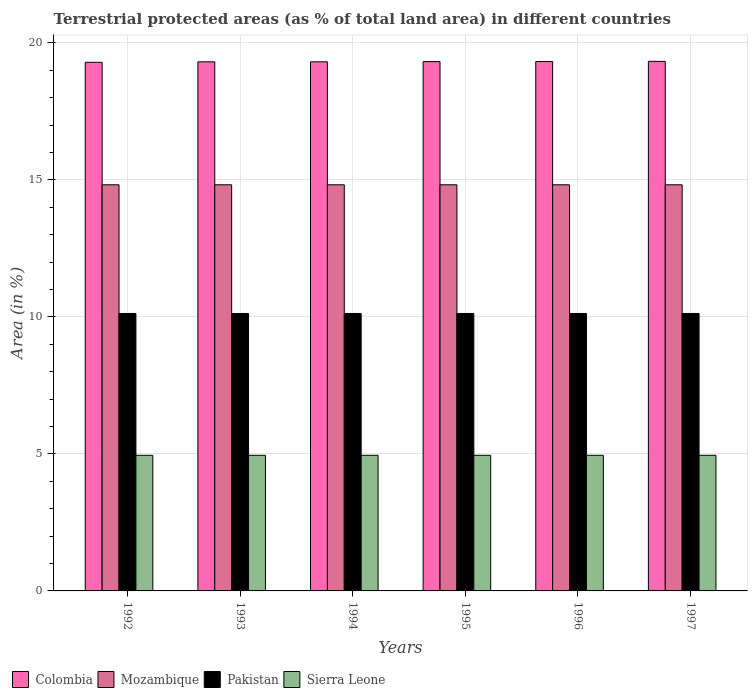How many bars are there on the 3rd tick from the left?
Offer a very short reply. 4. How many bars are there on the 2nd tick from the right?
Your answer should be compact. 4. What is the label of the 4th group of bars from the left?
Give a very brief answer. 1995. In how many cases, is the number of bars for a given year not equal to the number of legend labels?
Your answer should be very brief. 0. What is the percentage of terrestrial protected land in Mozambique in 1992?
Provide a short and direct response. 14.82. Across all years, what is the maximum percentage of terrestrial protected land in Colombia?
Offer a terse response. 19.33. Across all years, what is the minimum percentage of terrestrial protected land in Sierra Leone?
Make the answer very short. 4.95. What is the total percentage of terrestrial protected land in Pakistan in the graph?
Your answer should be very brief. 60.75. What is the difference between the percentage of terrestrial protected land in Sierra Leone in 1993 and the percentage of terrestrial protected land in Mozambique in 1994?
Your answer should be compact. -9.87. What is the average percentage of terrestrial protected land in Colombia per year?
Give a very brief answer. 19.31. In the year 1995, what is the difference between the percentage of terrestrial protected land in Mozambique and percentage of terrestrial protected land in Colombia?
Your answer should be very brief. -4.5. What is the ratio of the percentage of terrestrial protected land in Pakistan in 1993 to that in 1995?
Your response must be concise. 1. Is the percentage of terrestrial protected land in Pakistan in 1993 less than that in 1997?
Your answer should be very brief. No. What is the difference between the highest and the second highest percentage of terrestrial protected land in Sierra Leone?
Offer a terse response. 0. What is the difference between the highest and the lowest percentage of terrestrial protected land in Colombia?
Offer a very short reply. 0.03. Is it the case that in every year, the sum of the percentage of terrestrial protected land in Pakistan and percentage of terrestrial protected land in Colombia is greater than the sum of percentage of terrestrial protected land in Sierra Leone and percentage of terrestrial protected land in Mozambique?
Keep it short and to the point. No. How many bars are there?
Offer a terse response. 24. Are all the bars in the graph horizontal?
Provide a short and direct response. No. How many years are there in the graph?
Ensure brevity in your answer.  6. Where does the legend appear in the graph?
Provide a succinct answer. Bottom left. How many legend labels are there?
Keep it short and to the point. 4. What is the title of the graph?
Offer a terse response. Terrestrial protected areas (as % of total land area) in different countries. What is the label or title of the Y-axis?
Offer a very short reply. Area (in %). What is the Area (in %) of Colombia in 1992?
Your answer should be compact. 19.29. What is the Area (in %) in Mozambique in 1992?
Provide a short and direct response. 14.82. What is the Area (in %) of Pakistan in 1992?
Offer a very short reply. 10.13. What is the Area (in %) of Sierra Leone in 1992?
Provide a short and direct response. 4.95. What is the Area (in %) of Colombia in 1993?
Keep it short and to the point. 19.31. What is the Area (in %) in Mozambique in 1993?
Provide a short and direct response. 14.82. What is the Area (in %) of Pakistan in 1993?
Keep it short and to the point. 10.13. What is the Area (in %) of Sierra Leone in 1993?
Your answer should be compact. 4.95. What is the Area (in %) in Colombia in 1994?
Provide a short and direct response. 19.31. What is the Area (in %) in Mozambique in 1994?
Ensure brevity in your answer.  14.82. What is the Area (in %) of Pakistan in 1994?
Your answer should be very brief. 10.13. What is the Area (in %) of Sierra Leone in 1994?
Your answer should be very brief. 4.95. What is the Area (in %) in Colombia in 1995?
Your answer should be very brief. 19.32. What is the Area (in %) in Mozambique in 1995?
Provide a succinct answer. 14.82. What is the Area (in %) in Pakistan in 1995?
Offer a terse response. 10.13. What is the Area (in %) of Sierra Leone in 1995?
Keep it short and to the point. 4.95. What is the Area (in %) in Colombia in 1996?
Ensure brevity in your answer.  19.32. What is the Area (in %) of Mozambique in 1996?
Offer a terse response. 14.82. What is the Area (in %) in Pakistan in 1996?
Ensure brevity in your answer.  10.13. What is the Area (in %) in Sierra Leone in 1996?
Offer a very short reply. 4.95. What is the Area (in %) in Colombia in 1997?
Ensure brevity in your answer.  19.33. What is the Area (in %) of Mozambique in 1997?
Keep it short and to the point. 14.82. What is the Area (in %) in Pakistan in 1997?
Keep it short and to the point. 10.13. What is the Area (in %) of Sierra Leone in 1997?
Provide a succinct answer. 4.95. Across all years, what is the maximum Area (in %) in Colombia?
Offer a very short reply. 19.33. Across all years, what is the maximum Area (in %) of Mozambique?
Provide a short and direct response. 14.82. Across all years, what is the maximum Area (in %) in Pakistan?
Provide a short and direct response. 10.13. Across all years, what is the maximum Area (in %) of Sierra Leone?
Give a very brief answer. 4.95. Across all years, what is the minimum Area (in %) in Colombia?
Provide a short and direct response. 19.29. Across all years, what is the minimum Area (in %) of Mozambique?
Keep it short and to the point. 14.82. Across all years, what is the minimum Area (in %) of Pakistan?
Your answer should be compact. 10.13. Across all years, what is the minimum Area (in %) in Sierra Leone?
Your answer should be very brief. 4.95. What is the total Area (in %) in Colombia in the graph?
Make the answer very short. 115.87. What is the total Area (in %) in Mozambique in the graph?
Your answer should be compact. 88.93. What is the total Area (in %) of Pakistan in the graph?
Ensure brevity in your answer.  60.75. What is the total Area (in %) of Sierra Leone in the graph?
Offer a very short reply. 29.7. What is the difference between the Area (in %) of Colombia in 1992 and that in 1993?
Keep it short and to the point. -0.02. What is the difference between the Area (in %) in Pakistan in 1992 and that in 1993?
Ensure brevity in your answer.  0. What is the difference between the Area (in %) of Colombia in 1992 and that in 1994?
Ensure brevity in your answer.  -0.02. What is the difference between the Area (in %) in Mozambique in 1992 and that in 1994?
Provide a short and direct response. 0. What is the difference between the Area (in %) of Pakistan in 1992 and that in 1994?
Give a very brief answer. 0. What is the difference between the Area (in %) of Sierra Leone in 1992 and that in 1994?
Your response must be concise. 0. What is the difference between the Area (in %) in Colombia in 1992 and that in 1995?
Provide a succinct answer. -0.03. What is the difference between the Area (in %) in Colombia in 1992 and that in 1996?
Provide a short and direct response. -0.03. What is the difference between the Area (in %) in Mozambique in 1992 and that in 1996?
Give a very brief answer. 0. What is the difference between the Area (in %) in Colombia in 1992 and that in 1997?
Your response must be concise. -0.03. What is the difference between the Area (in %) in Sierra Leone in 1992 and that in 1997?
Your answer should be very brief. 0. What is the difference between the Area (in %) in Colombia in 1993 and that in 1994?
Make the answer very short. 0. What is the difference between the Area (in %) in Mozambique in 1993 and that in 1994?
Make the answer very short. 0. What is the difference between the Area (in %) in Pakistan in 1993 and that in 1994?
Make the answer very short. 0. What is the difference between the Area (in %) of Sierra Leone in 1993 and that in 1994?
Offer a terse response. 0. What is the difference between the Area (in %) in Colombia in 1993 and that in 1995?
Keep it short and to the point. -0.01. What is the difference between the Area (in %) in Mozambique in 1993 and that in 1995?
Provide a short and direct response. 0. What is the difference between the Area (in %) in Pakistan in 1993 and that in 1995?
Your answer should be compact. 0. What is the difference between the Area (in %) in Colombia in 1993 and that in 1996?
Your response must be concise. -0.01. What is the difference between the Area (in %) in Mozambique in 1993 and that in 1996?
Ensure brevity in your answer.  0. What is the difference between the Area (in %) of Colombia in 1993 and that in 1997?
Give a very brief answer. -0.02. What is the difference between the Area (in %) in Mozambique in 1993 and that in 1997?
Offer a very short reply. 0. What is the difference between the Area (in %) in Pakistan in 1993 and that in 1997?
Offer a terse response. 0. What is the difference between the Area (in %) of Sierra Leone in 1993 and that in 1997?
Keep it short and to the point. 0. What is the difference between the Area (in %) in Colombia in 1994 and that in 1995?
Make the answer very short. -0.01. What is the difference between the Area (in %) in Mozambique in 1994 and that in 1995?
Your response must be concise. 0. What is the difference between the Area (in %) in Pakistan in 1994 and that in 1995?
Make the answer very short. 0. What is the difference between the Area (in %) in Sierra Leone in 1994 and that in 1995?
Provide a succinct answer. 0. What is the difference between the Area (in %) of Colombia in 1994 and that in 1996?
Give a very brief answer. -0.01. What is the difference between the Area (in %) in Mozambique in 1994 and that in 1996?
Give a very brief answer. 0. What is the difference between the Area (in %) in Colombia in 1994 and that in 1997?
Your answer should be compact. -0.02. What is the difference between the Area (in %) of Pakistan in 1994 and that in 1997?
Keep it short and to the point. 0. What is the difference between the Area (in %) in Colombia in 1995 and that in 1996?
Offer a very short reply. -0. What is the difference between the Area (in %) in Mozambique in 1995 and that in 1996?
Offer a very short reply. 0. What is the difference between the Area (in %) in Sierra Leone in 1995 and that in 1996?
Ensure brevity in your answer.  0. What is the difference between the Area (in %) in Colombia in 1995 and that in 1997?
Offer a terse response. -0.01. What is the difference between the Area (in %) in Pakistan in 1995 and that in 1997?
Give a very brief answer. 0. What is the difference between the Area (in %) in Sierra Leone in 1995 and that in 1997?
Make the answer very short. 0. What is the difference between the Area (in %) of Colombia in 1996 and that in 1997?
Provide a short and direct response. -0.01. What is the difference between the Area (in %) in Sierra Leone in 1996 and that in 1997?
Your answer should be very brief. 0. What is the difference between the Area (in %) of Colombia in 1992 and the Area (in %) of Mozambique in 1993?
Provide a short and direct response. 4.47. What is the difference between the Area (in %) of Colombia in 1992 and the Area (in %) of Pakistan in 1993?
Offer a terse response. 9.17. What is the difference between the Area (in %) of Colombia in 1992 and the Area (in %) of Sierra Leone in 1993?
Provide a short and direct response. 14.34. What is the difference between the Area (in %) of Mozambique in 1992 and the Area (in %) of Pakistan in 1993?
Provide a succinct answer. 4.7. What is the difference between the Area (in %) of Mozambique in 1992 and the Area (in %) of Sierra Leone in 1993?
Keep it short and to the point. 9.87. What is the difference between the Area (in %) of Pakistan in 1992 and the Area (in %) of Sierra Leone in 1993?
Your response must be concise. 5.18. What is the difference between the Area (in %) of Colombia in 1992 and the Area (in %) of Mozambique in 1994?
Make the answer very short. 4.47. What is the difference between the Area (in %) in Colombia in 1992 and the Area (in %) in Pakistan in 1994?
Provide a succinct answer. 9.17. What is the difference between the Area (in %) in Colombia in 1992 and the Area (in %) in Sierra Leone in 1994?
Your answer should be compact. 14.34. What is the difference between the Area (in %) of Mozambique in 1992 and the Area (in %) of Pakistan in 1994?
Provide a succinct answer. 4.7. What is the difference between the Area (in %) of Mozambique in 1992 and the Area (in %) of Sierra Leone in 1994?
Ensure brevity in your answer.  9.87. What is the difference between the Area (in %) of Pakistan in 1992 and the Area (in %) of Sierra Leone in 1994?
Offer a terse response. 5.18. What is the difference between the Area (in %) of Colombia in 1992 and the Area (in %) of Mozambique in 1995?
Provide a succinct answer. 4.47. What is the difference between the Area (in %) of Colombia in 1992 and the Area (in %) of Pakistan in 1995?
Your answer should be compact. 9.17. What is the difference between the Area (in %) of Colombia in 1992 and the Area (in %) of Sierra Leone in 1995?
Make the answer very short. 14.34. What is the difference between the Area (in %) in Mozambique in 1992 and the Area (in %) in Pakistan in 1995?
Your response must be concise. 4.7. What is the difference between the Area (in %) of Mozambique in 1992 and the Area (in %) of Sierra Leone in 1995?
Keep it short and to the point. 9.87. What is the difference between the Area (in %) of Pakistan in 1992 and the Area (in %) of Sierra Leone in 1995?
Your response must be concise. 5.18. What is the difference between the Area (in %) of Colombia in 1992 and the Area (in %) of Mozambique in 1996?
Provide a succinct answer. 4.47. What is the difference between the Area (in %) of Colombia in 1992 and the Area (in %) of Pakistan in 1996?
Provide a succinct answer. 9.17. What is the difference between the Area (in %) of Colombia in 1992 and the Area (in %) of Sierra Leone in 1996?
Ensure brevity in your answer.  14.34. What is the difference between the Area (in %) in Mozambique in 1992 and the Area (in %) in Pakistan in 1996?
Offer a very short reply. 4.7. What is the difference between the Area (in %) in Mozambique in 1992 and the Area (in %) in Sierra Leone in 1996?
Offer a very short reply. 9.87. What is the difference between the Area (in %) of Pakistan in 1992 and the Area (in %) of Sierra Leone in 1996?
Your response must be concise. 5.18. What is the difference between the Area (in %) of Colombia in 1992 and the Area (in %) of Mozambique in 1997?
Your response must be concise. 4.47. What is the difference between the Area (in %) of Colombia in 1992 and the Area (in %) of Pakistan in 1997?
Ensure brevity in your answer.  9.17. What is the difference between the Area (in %) in Colombia in 1992 and the Area (in %) in Sierra Leone in 1997?
Your response must be concise. 14.34. What is the difference between the Area (in %) in Mozambique in 1992 and the Area (in %) in Pakistan in 1997?
Provide a short and direct response. 4.7. What is the difference between the Area (in %) in Mozambique in 1992 and the Area (in %) in Sierra Leone in 1997?
Your response must be concise. 9.87. What is the difference between the Area (in %) of Pakistan in 1992 and the Area (in %) of Sierra Leone in 1997?
Provide a short and direct response. 5.18. What is the difference between the Area (in %) of Colombia in 1993 and the Area (in %) of Mozambique in 1994?
Keep it short and to the point. 4.49. What is the difference between the Area (in %) in Colombia in 1993 and the Area (in %) in Pakistan in 1994?
Keep it short and to the point. 9.18. What is the difference between the Area (in %) in Colombia in 1993 and the Area (in %) in Sierra Leone in 1994?
Your response must be concise. 14.36. What is the difference between the Area (in %) in Mozambique in 1993 and the Area (in %) in Pakistan in 1994?
Give a very brief answer. 4.7. What is the difference between the Area (in %) of Mozambique in 1993 and the Area (in %) of Sierra Leone in 1994?
Make the answer very short. 9.87. What is the difference between the Area (in %) of Pakistan in 1993 and the Area (in %) of Sierra Leone in 1994?
Keep it short and to the point. 5.18. What is the difference between the Area (in %) of Colombia in 1993 and the Area (in %) of Mozambique in 1995?
Ensure brevity in your answer.  4.49. What is the difference between the Area (in %) of Colombia in 1993 and the Area (in %) of Pakistan in 1995?
Offer a very short reply. 9.18. What is the difference between the Area (in %) in Colombia in 1993 and the Area (in %) in Sierra Leone in 1995?
Give a very brief answer. 14.36. What is the difference between the Area (in %) in Mozambique in 1993 and the Area (in %) in Pakistan in 1995?
Provide a succinct answer. 4.7. What is the difference between the Area (in %) of Mozambique in 1993 and the Area (in %) of Sierra Leone in 1995?
Offer a terse response. 9.87. What is the difference between the Area (in %) of Pakistan in 1993 and the Area (in %) of Sierra Leone in 1995?
Offer a very short reply. 5.18. What is the difference between the Area (in %) in Colombia in 1993 and the Area (in %) in Mozambique in 1996?
Provide a succinct answer. 4.49. What is the difference between the Area (in %) of Colombia in 1993 and the Area (in %) of Pakistan in 1996?
Your answer should be very brief. 9.18. What is the difference between the Area (in %) in Colombia in 1993 and the Area (in %) in Sierra Leone in 1996?
Ensure brevity in your answer.  14.36. What is the difference between the Area (in %) of Mozambique in 1993 and the Area (in %) of Pakistan in 1996?
Give a very brief answer. 4.7. What is the difference between the Area (in %) in Mozambique in 1993 and the Area (in %) in Sierra Leone in 1996?
Offer a terse response. 9.87. What is the difference between the Area (in %) in Pakistan in 1993 and the Area (in %) in Sierra Leone in 1996?
Make the answer very short. 5.18. What is the difference between the Area (in %) in Colombia in 1993 and the Area (in %) in Mozambique in 1997?
Your response must be concise. 4.49. What is the difference between the Area (in %) in Colombia in 1993 and the Area (in %) in Pakistan in 1997?
Give a very brief answer. 9.18. What is the difference between the Area (in %) in Colombia in 1993 and the Area (in %) in Sierra Leone in 1997?
Your answer should be compact. 14.36. What is the difference between the Area (in %) in Mozambique in 1993 and the Area (in %) in Pakistan in 1997?
Ensure brevity in your answer.  4.7. What is the difference between the Area (in %) of Mozambique in 1993 and the Area (in %) of Sierra Leone in 1997?
Offer a very short reply. 9.87. What is the difference between the Area (in %) of Pakistan in 1993 and the Area (in %) of Sierra Leone in 1997?
Offer a very short reply. 5.18. What is the difference between the Area (in %) of Colombia in 1994 and the Area (in %) of Mozambique in 1995?
Your answer should be very brief. 4.49. What is the difference between the Area (in %) of Colombia in 1994 and the Area (in %) of Pakistan in 1995?
Your answer should be compact. 9.18. What is the difference between the Area (in %) in Colombia in 1994 and the Area (in %) in Sierra Leone in 1995?
Make the answer very short. 14.36. What is the difference between the Area (in %) of Mozambique in 1994 and the Area (in %) of Pakistan in 1995?
Make the answer very short. 4.7. What is the difference between the Area (in %) in Mozambique in 1994 and the Area (in %) in Sierra Leone in 1995?
Ensure brevity in your answer.  9.87. What is the difference between the Area (in %) in Pakistan in 1994 and the Area (in %) in Sierra Leone in 1995?
Your answer should be compact. 5.18. What is the difference between the Area (in %) of Colombia in 1994 and the Area (in %) of Mozambique in 1996?
Ensure brevity in your answer.  4.49. What is the difference between the Area (in %) in Colombia in 1994 and the Area (in %) in Pakistan in 1996?
Give a very brief answer. 9.18. What is the difference between the Area (in %) in Colombia in 1994 and the Area (in %) in Sierra Leone in 1996?
Keep it short and to the point. 14.36. What is the difference between the Area (in %) in Mozambique in 1994 and the Area (in %) in Pakistan in 1996?
Your answer should be compact. 4.7. What is the difference between the Area (in %) of Mozambique in 1994 and the Area (in %) of Sierra Leone in 1996?
Make the answer very short. 9.87. What is the difference between the Area (in %) of Pakistan in 1994 and the Area (in %) of Sierra Leone in 1996?
Offer a very short reply. 5.18. What is the difference between the Area (in %) in Colombia in 1994 and the Area (in %) in Mozambique in 1997?
Keep it short and to the point. 4.49. What is the difference between the Area (in %) of Colombia in 1994 and the Area (in %) of Pakistan in 1997?
Offer a very short reply. 9.18. What is the difference between the Area (in %) in Colombia in 1994 and the Area (in %) in Sierra Leone in 1997?
Keep it short and to the point. 14.36. What is the difference between the Area (in %) of Mozambique in 1994 and the Area (in %) of Pakistan in 1997?
Keep it short and to the point. 4.7. What is the difference between the Area (in %) in Mozambique in 1994 and the Area (in %) in Sierra Leone in 1997?
Keep it short and to the point. 9.87. What is the difference between the Area (in %) in Pakistan in 1994 and the Area (in %) in Sierra Leone in 1997?
Offer a very short reply. 5.18. What is the difference between the Area (in %) in Colombia in 1995 and the Area (in %) in Mozambique in 1996?
Provide a succinct answer. 4.5. What is the difference between the Area (in %) of Colombia in 1995 and the Area (in %) of Pakistan in 1996?
Give a very brief answer. 9.19. What is the difference between the Area (in %) of Colombia in 1995 and the Area (in %) of Sierra Leone in 1996?
Ensure brevity in your answer.  14.37. What is the difference between the Area (in %) of Mozambique in 1995 and the Area (in %) of Pakistan in 1996?
Offer a very short reply. 4.7. What is the difference between the Area (in %) of Mozambique in 1995 and the Area (in %) of Sierra Leone in 1996?
Make the answer very short. 9.87. What is the difference between the Area (in %) of Pakistan in 1995 and the Area (in %) of Sierra Leone in 1996?
Make the answer very short. 5.18. What is the difference between the Area (in %) in Colombia in 1995 and the Area (in %) in Mozambique in 1997?
Make the answer very short. 4.5. What is the difference between the Area (in %) of Colombia in 1995 and the Area (in %) of Pakistan in 1997?
Give a very brief answer. 9.19. What is the difference between the Area (in %) in Colombia in 1995 and the Area (in %) in Sierra Leone in 1997?
Your response must be concise. 14.37. What is the difference between the Area (in %) in Mozambique in 1995 and the Area (in %) in Pakistan in 1997?
Provide a succinct answer. 4.7. What is the difference between the Area (in %) in Mozambique in 1995 and the Area (in %) in Sierra Leone in 1997?
Give a very brief answer. 9.87. What is the difference between the Area (in %) in Pakistan in 1995 and the Area (in %) in Sierra Leone in 1997?
Offer a very short reply. 5.18. What is the difference between the Area (in %) of Colombia in 1996 and the Area (in %) of Mozambique in 1997?
Your answer should be compact. 4.5. What is the difference between the Area (in %) of Colombia in 1996 and the Area (in %) of Pakistan in 1997?
Provide a succinct answer. 9.19. What is the difference between the Area (in %) in Colombia in 1996 and the Area (in %) in Sierra Leone in 1997?
Offer a terse response. 14.37. What is the difference between the Area (in %) in Mozambique in 1996 and the Area (in %) in Pakistan in 1997?
Ensure brevity in your answer.  4.7. What is the difference between the Area (in %) of Mozambique in 1996 and the Area (in %) of Sierra Leone in 1997?
Provide a short and direct response. 9.87. What is the difference between the Area (in %) in Pakistan in 1996 and the Area (in %) in Sierra Leone in 1997?
Offer a terse response. 5.18. What is the average Area (in %) of Colombia per year?
Provide a succinct answer. 19.31. What is the average Area (in %) of Mozambique per year?
Your answer should be compact. 14.82. What is the average Area (in %) in Pakistan per year?
Keep it short and to the point. 10.13. What is the average Area (in %) of Sierra Leone per year?
Your answer should be compact. 4.95. In the year 1992, what is the difference between the Area (in %) in Colombia and Area (in %) in Mozambique?
Your answer should be very brief. 4.47. In the year 1992, what is the difference between the Area (in %) of Colombia and Area (in %) of Pakistan?
Give a very brief answer. 9.17. In the year 1992, what is the difference between the Area (in %) in Colombia and Area (in %) in Sierra Leone?
Your answer should be compact. 14.34. In the year 1992, what is the difference between the Area (in %) of Mozambique and Area (in %) of Pakistan?
Provide a short and direct response. 4.7. In the year 1992, what is the difference between the Area (in %) of Mozambique and Area (in %) of Sierra Leone?
Give a very brief answer. 9.87. In the year 1992, what is the difference between the Area (in %) in Pakistan and Area (in %) in Sierra Leone?
Your answer should be compact. 5.18. In the year 1993, what is the difference between the Area (in %) of Colombia and Area (in %) of Mozambique?
Your response must be concise. 4.49. In the year 1993, what is the difference between the Area (in %) in Colombia and Area (in %) in Pakistan?
Keep it short and to the point. 9.18. In the year 1993, what is the difference between the Area (in %) in Colombia and Area (in %) in Sierra Leone?
Offer a terse response. 14.36. In the year 1993, what is the difference between the Area (in %) in Mozambique and Area (in %) in Pakistan?
Make the answer very short. 4.7. In the year 1993, what is the difference between the Area (in %) in Mozambique and Area (in %) in Sierra Leone?
Give a very brief answer. 9.87. In the year 1993, what is the difference between the Area (in %) in Pakistan and Area (in %) in Sierra Leone?
Your response must be concise. 5.18. In the year 1994, what is the difference between the Area (in %) of Colombia and Area (in %) of Mozambique?
Provide a succinct answer. 4.49. In the year 1994, what is the difference between the Area (in %) of Colombia and Area (in %) of Pakistan?
Ensure brevity in your answer.  9.18. In the year 1994, what is the difference between the Area (in %) in Colombia and Area (in %) in Sierra Leone?
Offer a very short reply. 14.36. In the year 1994, what is the difference between the Area (in %) of Mozambique and Area (in %) of Pakistan?
Offer a very short reply. 4.7. In the year 1994, what is the difference between the Area (in %) of Mozambique and Area (in %) of Sierra Leone?
Give a very brief answer. 9.87. In the year 1994, what is the difference between the Area (in %) of Pakistan and Area (in %) of Sierra Leone?
Make the answer very short. 5.18. In the year 1995, what is the difference between the Area (in %) of Colombia and Area (in %) of Mozambique?
Give a very brief answer. 4.5. In the year 1995, what is the difference between the Area (in %) of Colombia and Area (in %) of Pakistan?
Ensure brevity in your answer.  9.19. In the year 1995, what is the difference between the Area (in %) in Colombia and Area (in %) in Sierra Leone?
Provide a short and direct response. 14.37. In the year 1995, what is the difference between the Area (in %) of Mozambique and Area (in %) of Pakistan?
Your answer should be very brief. 4.7. In the year 1995, what is the difference between the Area (in %) of Mozambique and Area (in %) of Sierra Leone?
Give a very brief answer. 9.87. In the year 1995, what is the difference between the Area (in %) of Pakistan and Area (in %) of Sierra Leone?
Your response must be concise. 5.18. In the year 1996, what is the difference between the Area (in %) of Colombia and Area (in %) of Mozambique?
Offer a terse response. 4.5. In the year 1996, what is the difference between the Area (in %) in Colombia and Area (in %) in Pakistan?
Your answer should be compact. 9.19. In the year 1996, what is the difference between the Area (in %) of Colombia and Area (in %) of Sierra Leone?
Make the answer very short. 14.37. In the year 1996, what is the difference between the Area (in %) in Mozambique and Area (in %) in Pakistan?
Make the answer very short. 4.7. In the year 1996, what is the difference between the Area (in %) in Mozambique and Area (in %) in Sierra Leone?
Give a very brief answer. 9.87. In the year 1996, what is the difference between the Area (in %) of Pakistan and Area (in %) of Sierra Leone?
Keep it short and to the point. 5.18. In the year 1997, what is the difference between the Area (in %) in Colombia and Area (in %) in Mozambique?
Ensure brevity in your answer.  4.5. In the year 1997, what is the difference between the Area (in %) in Colombia and Area (in %) in Pakistan?
Your response must be concise. 9.2. In the year 1997, what is the difference between the Area (in %) in Colombia and Area (in %) in Sierra Leone?
Ensure brevity in your answer.  14.38. In the year 1997, what is the difference between the Area (in %) in Mozambique and Area (in %) in Pakistan?
Your answer should be compact. 4.7. In the year 1997, what is the difference between the Area (in %) of Mozambique and Area (in %) of Sierra Leone?
Make the answer very short. 9.87. In the year 1997, what is the difference between the Area (in %) of Pakistan and Area (in %) of Sierra Leone?
Provide a succinct answer. 5.18. What is the ratio of the Area (in %) of Mozambique in 1992 to that in 1993?
Provide a short and direct response. 1. What is the ratio of the Area (in %) of Colombia in 1992 to that in 1994?
Give a very brief answer. 1. What is the ratio of the Area (in %) of Sierra Leone in 1992 to that in 1994?
Your answer should be very brief. 1. What is the ratio of the Area (in %) in Colombia in 1992 to that in 1995?
Provide a short and direct response. 1. What is the ratio of the Area (in %) in Pakistan in 1992 to that in 1995?
Offer a very short reply. 1. What is the ratio of the Area (in %) in Colombia in 1992 to that in 1996?
Offer a terse response. 1. What is the ratio of the Area (in %) in Colombia in 1992 to that in 1997?
Provide a short and direct response. 1. What is the ratio of the Area (in %) of Mozambique in 1992 to that in 1997?
Provide a succinct answer. 1. What is the ratio of the Area (in %) of Pakistan in 1992 to that in 1997?
Keep it short and to the point. 1. What is the ratio of the Area (in %) in Sierra Leone in 1993 to that in 1994?
Provide a succinct answer. 1. What is the ratio of the Area (in %) of Colombia in 1993 to that in 1995?
Provide a succinct answer. 1. What is the ratio of the Area (in %) in Mozambique in 1993 to that in 1995?
Offer a very short reply. 1. What is the ratio of the Area (in %) of Pakistan in 1993 to that in 1995?
Provide a succinct answer. 1. What is the ratio of the Area (in %) in Sierra Leone in 1993 to that in 1995?
Provide a short and direct response. 1. What is the ratio of the Area (in %) in Colombia in 1993 to that in 1996?
Provide a succinct answer. 1. What is the ratio of the Area (in %) of Pakistan in 1993 to that in 1996?
Make the answer very short. 1. What is the ratio of the Area (in %) of Sierra Leone in 1993 to that in 1996?
Provide a succinct answer. 1. What is the ratio of the Area (in %) of Pakistan in 1993 to that in 1997?
Provide a short and direct response. 1. What is the ratio of the Area (in %) in Sierra Leone in 1993 to that in 1997?
Your response must be concise. 1. What is the ratio of the Area (in %) of Pakistan in 1994 to that in 1995?
Provide a short and direct response. 1. What is the ratio of the Area (in %) of Pakistan in 1994 to that in 1997?
Offer a terse response. 1. What is the ratio of the Area (in %) of Pakistan in 1995 to that in 1996?
Ensure brevity in your answer.  1. What is the ratio of the Area (in %) of Pakistan in 1995 to that in 1997?
Provide a short and direct response. 1. What is the ratio of the Area (in %) of Sierra Leone in 1995 to that in 1997?
Make the answer very short. 1. What is the ratio of the Area (in %) in Colombia in 1996 to that in 1997?
Your response must be concise. 1. What is the ratio of the Area (in %) of Mozambique in 1996 to that in 1997?
Make the answer very short. 1. What is the ratio of the Area (in %) of Pakistan in 1996 to that in 1997?
Ensure brevity in your answer.  1. What is the ratio of the Area (in %) of Sierra Leone in 1996 to that in 1997?
Ensure brevity in your answer.  1. What is the difference between the highest and the second highest Area (in %) of Colombia?
Ensure brevity in your answer.  0.01. What is the difference between the highest and the lowest Area (in %) in Colombia?
Your answer should be very brief. 0.03. What is the difference between the highest and the lowest Area (in %) of Pakistan?
Your response must be concise. 0. What is the difference between the highest and the lowest Area (in %) in Sierra Leone?
Your answer should be compact. 0. 